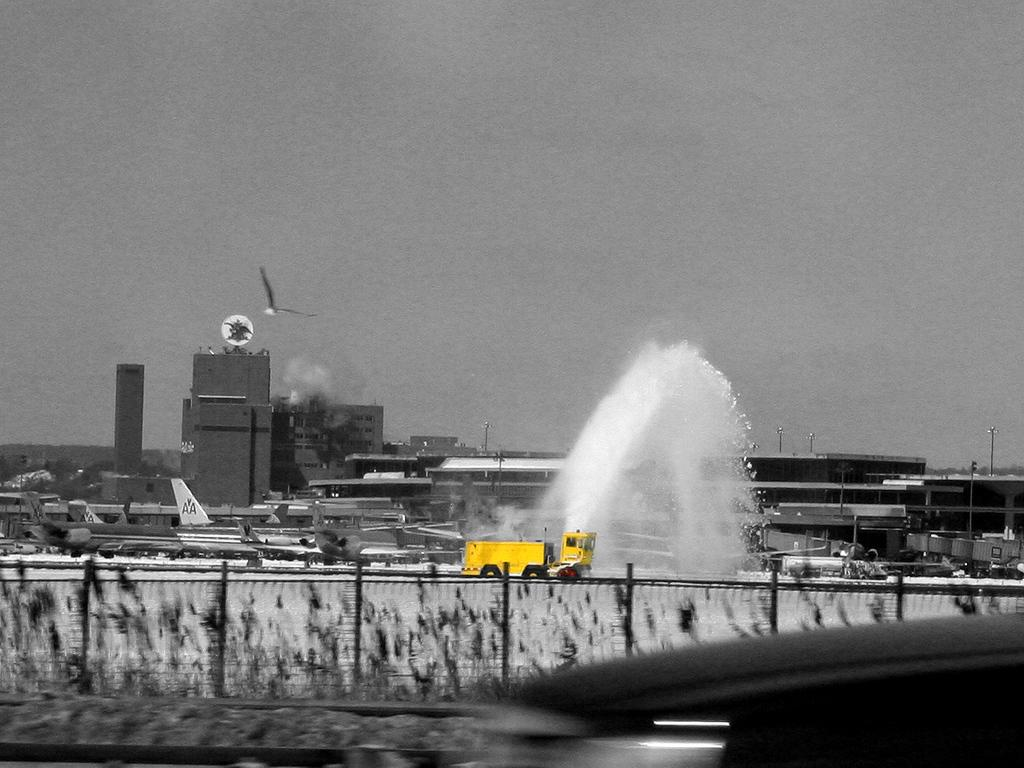What is: What type of barrier is present in the image? There is a fencing in the image. What can be seen behind the fencing? There are airplanes behind the fencing. What mode of transportation is visible in the image? There is a vehicle visible in the image. What is the weather condition in the image? There is snow in the image. What type of structures are present in the image? There are buildings in the image. What type of pest can be seen crawling on the dinner table in the image? There is no dinner table or pest present in the image. What happens when the vehicle bursts in the image? There is no vehicle bursting in the image; the vehicle is stationary. 